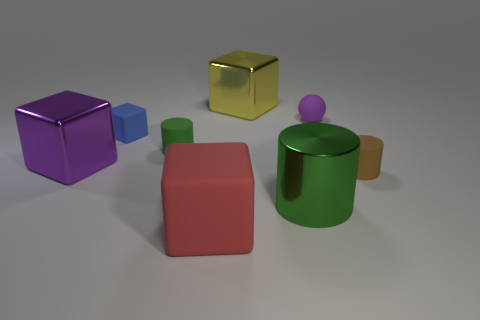There is a cylinder that is to the left of the metallic thing that is on the right side of the yellow cube; how many green rubber cylinders are in front of it? In your description, you've identified a specific cylinder to the left of a metallic object which is near a yellow cube. The image shows there are no green rubber cylinders directly in front of this cylinder, so the answer is zero. However, I'd like to add that the green cylinder is rubber-like in texture and is accompanied by other colorful geometric shapes arranged on a surface, each with their own unique appearance and material qualities, contributing to a diverse array of simple 3D shapes in this composition. 